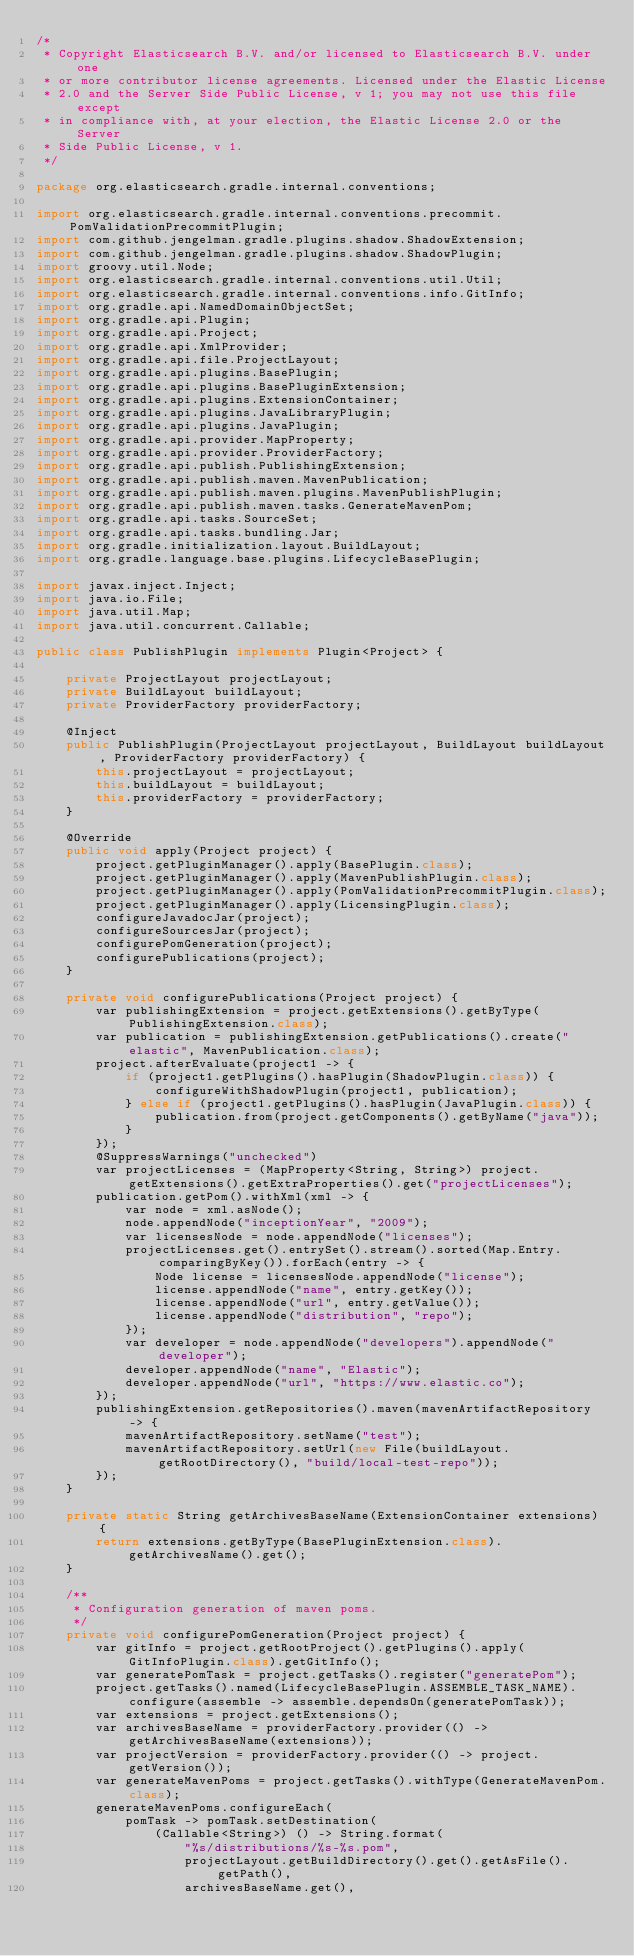Convert code to text. <code><loc_0><loc_0><loc_500><loc_500><_Java_>/*
 * Copyright Elasticsearch B.V. and/or licensed to Elasticsearch B.V. under one
 * or more contributor license agreements. Licensed under the Elastic License
 * 2.0 and the Server Side Public License, v 1; you may not use this file except
 * in compliance with, at your election, the Elastic License 2.0 or the Server
 * Side Public License, v 1.
 */

package org.elasticsearch.gradle.internal.conventions;

import org.elasticsearch.gradle.internal.conventions.precommit.PomValidationPrecommitPlugin;
import com.github.jengelman.gradle.plugins.shadow.ShadowExtension;
import com.github.jengelman.gradle.plugins.shadow.ShadowPlugin;
import groovy.util.Node;
import org.elasticsearch.gradle.internal.conventions.util.Util;
import org.elasticsearch.gradle.internal.conventions.info.GitInfo;
import org.gradle.api.NamedDomainObjectSet;
import org.gradle.api.Plugin;
import org.gradle.api.Project;
import org.gradle.api.XmlProvider;
import org.gradle.api.file.ProjectLayout;
import org.gradle.api.plugins.BasePlugin;
import org.gradle.api.plugins.BasePluginExtension;
import org.gradle.api.plugins.ExtensionContainer;
import org.gradle.api.plugins.JavaLibraryPlugin;
import org.gradle.api.plugins.JavaPlugin;
import org.gradle.api.provider.MapProperty;
import org.gradle.api.provider.ProviderFactory;
import org.gradle.api.publish.PublishingExtension;
import org.gradle.api.publish.maven.MavenPublication;
import org.gradle.api.publish.maven.plugins.MavenPublishPlugin;
import org.gradle.api.publish.maven.tasks.GenerateMavenPom;
import org.gradle.api.tasks.SourceSet;
import org.gradle.api.tasks.bundling.Jar;
import org.gradle.initialization.layout.BuildLayout;
import org.gradle.language.base.plugins.LifecycleBasePlugin;

import javax.inject.Inject;
import java.io.File;
import java.util.Map;
import java.util.concurrent.Callable;

public class PublishPlugin implements Plugin<Project> {

    private ProjectLayout projectLayout;
    private BuildLayout buildLayout;
    private ProviderFactory providerFactory;

    @Inject
    public PublishPlugin(ProjectLayout projectLayout, BuildLayout buildLayout, ProviderFactory providerFactory) {
        this.projectLayout = projectLayout;
        this.buildLayout = buildLayout;
        this.providerFactory = providerFactory;
    }

    @Override
    public void apply(Project project) {
        project.getPluginManager().apply(BasePlugin.class);
        project.getPluginManager().apply(MavenPublishPlugin.class);
        project.getPluginManager().apply(PomValidationPrecommitPlugin.class);
        project.getPluginManager().apply(LicensingPlugin.class);
        configureJavadocJar(project);
        configureSourcesJar(project);
        configurePomGeneration(project);
        configurePublications(project);
    }

    private void configurePublications(Project project) {
        var publishingExtension = project.getExtensions().getByType(PublishingExtension.class);
        var publication = publishingExtension.getPublications().create("elastic", MavenPublication.class);
        project.afterEvaluate(project1 -> {
            if (project1.getPlugins().hasPlugin(ShadowPlugin.class)) {
                configureWithShadowPlugin(project1, publication);
            } else if (project1.getPlugins().hasPlugin(JavaPlugin.class)) {
                publication.from(project.getComponents().getByName("java"));
            }
        });
        @SuppressWarnings("unchecked")
        var projectLicenses = (MapProperty<String, String>) project.getExtensions().getExtraProperties().get("projectLicenses");
        publication.getPom().withXml(xml -> {
            var node = xml.asNode();
            node.appendNode("inceptionYear", "2009");
            var licensesNode = node.appendNode("licenses");
            projectLicenses.get().entrySet().stream().sorted(Map.Entry.comparingByKey()).forEach(entry -> {
                Node license = licensesNode.appendNode("license");
                license.appendNode("name", entry.getKey());
                license.appendNode("url", entry.getValue());
                license.appendNode("distribution", "repo");
            });
            var developer = node.appendNode("developers").appendNode("developer");
            developer.appendNode("name", "Elastic");
            developer.appendNode("url", "https://www.elastic.co");
        });
        publishingExtension.getRepositories().maven(mavenArtifactRepository -> {
            mavenArtifactRepository.setName("test");
            mavenArtifactRepository.setUrl(new File(buildLayout.getRootDirectory(), "build/local-test-repo"));
        });
    }

    private static String getArchivesBaseName(ExtensionContainer extensions) {
        return extensions.getByType(BasePluginExtension.class).getArchivesName().get();
    }

    /**
     * Configuration generation of maven poms.
     */
    private void configurePomGeneration(Project project) {
        var gitInfo = project.getRootProject().getPlugins().apply(GitInfoPlugin.class).getGitInfo();
        var generatePomTask = project.getTasks().register("generatePom");
        project.getTasks().named(LifecycleBasePlugin.ASSEMBLE_TASK_NAME).configure(assemble -> assemble.dependsOn(generatePomTask));
        var extensions = project.getExtensions();
        var archivesBaseName = providerFactory.provider(() -> getArchivesBaseName(extensions));
        var projectVersion = providerFactory.provider(() -> project.getVersion());
        var generateMavenPoms = project.getTasks().withType(GenerateMavenPom.class);
        generateMavenPoms.configureEach(
            pomTask -> pomTask.setDestination(
                (Callable<String>) () -> String.format(
                    "%s/distributions/%s-%s.pom",
                    projectLayout.getBuildDirectory().get().getAsFile().getPath(),
                    archivesBaseName.get(),</code> 